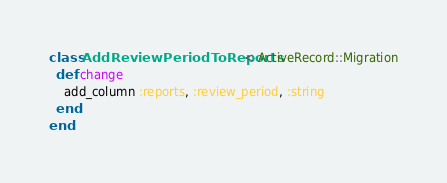<code> <loc_0><loc_0><loc_500><loc_500><_Ruby_>class AddReviewPeriodToReports < ActiveRecord::Migration
  def change
    add_column :reports, :review_period, :string
  end
end
</code> 